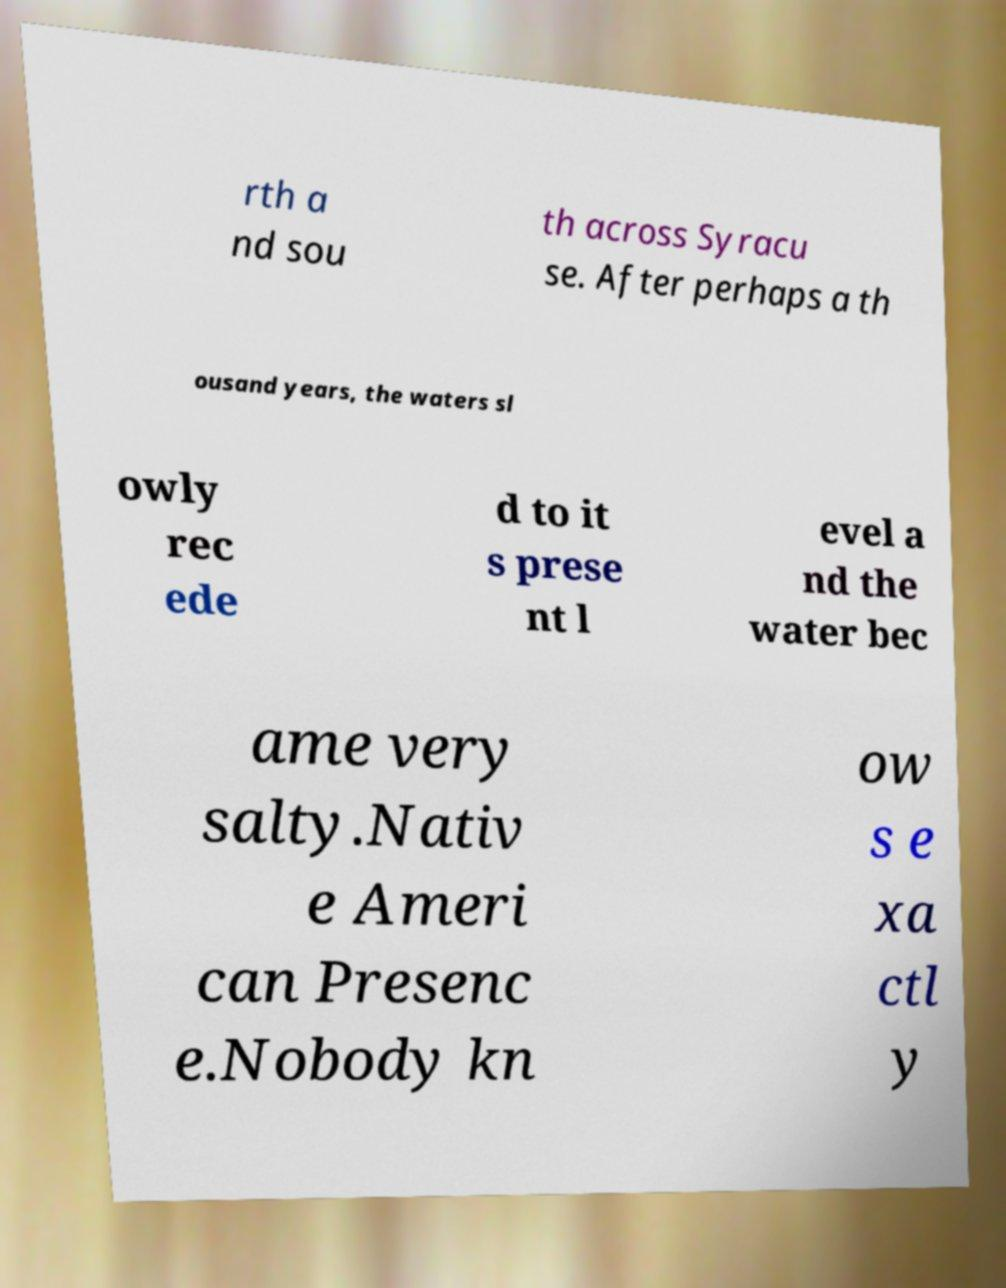There's text embedded in this image that I need extracted. Can you transcribe it verbatim? rth a nd sou th across Syracu se. After perhaps a th ousand years, the waters sl owly rec ede d to it s prese nt l evel a nd the water bec ame very salty.Nativ e Ameri can Presenc e.Nobody kn ow s e xa ctl y 